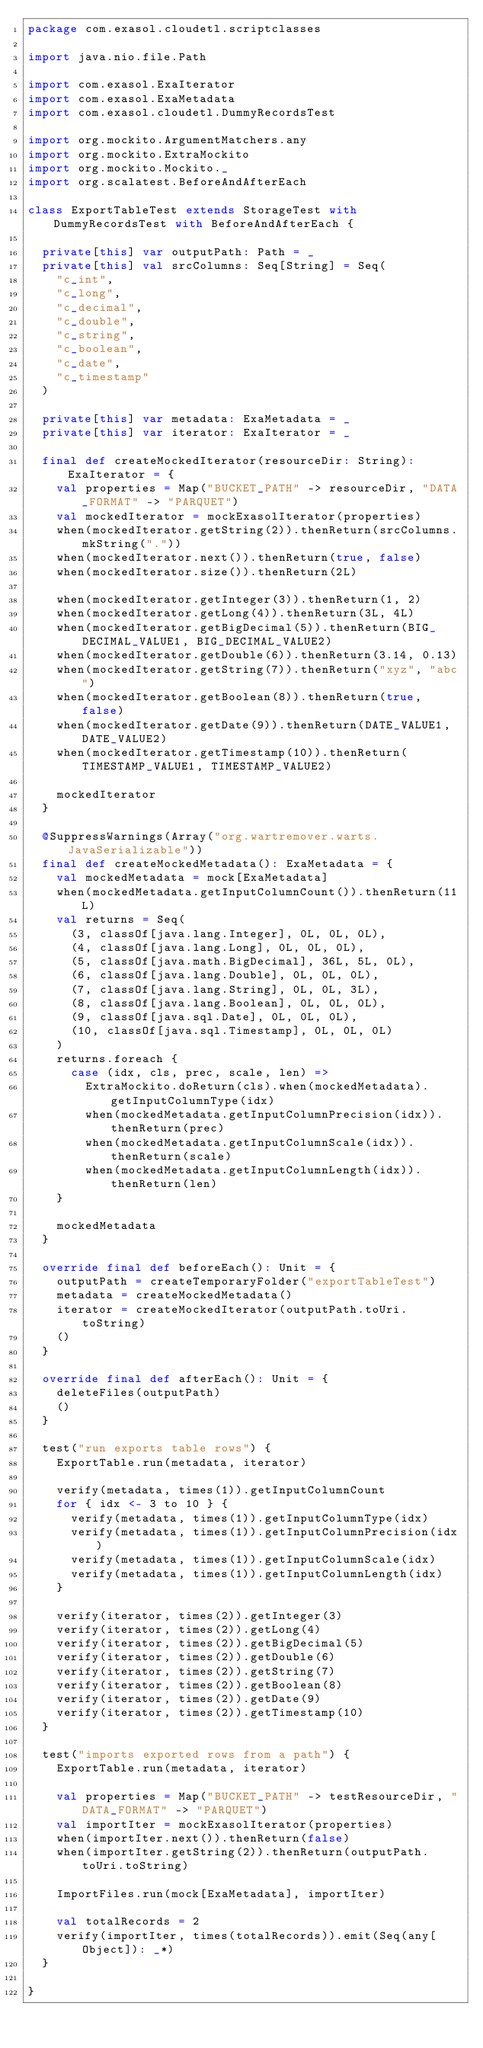Convert code to text. <code><loc_0><loc_0><loc_500><loc_500><_Scala_>package com.exasol.cloudetl.scriptclasses

import java.nio.file.Path

import com.exasol.ExaIterator
import com.exasol.ExaMetadata
import com.exasol.cloudetl.DummyRecordsTest

import org.mockito.ArgumentMatchers.any
import org.mockito.ExtraMockito
import org.mockito.Mockito._
import org.scalatest.BeforeAndAfterEach

class ExportTableTest extends StorageTest with DummyRecordsTest with BeforeAndAfterEach {

  private[this] var outputPath: Path = _
  private[this] val srcColumns: Seq[String] = Seq(
    "c_int",
    "c_long",
    "c_decimal",
    "c_double",
    "c_string",
    "c_boolean",
    "c_date",
    "c_timestamp"
  )

  private[this] var metadata: ExaMetadata = _
  private[this] var iterator: ExaIterator = _

  final def createMockedIterator(resourceDir: String): ExaIterator = {
    val properties = Map("BUCKET_PATH" -> resourceDir, "DATA_FORMAT" -> "PARQUET")
    val mockedIterator = mockExasolIterator(properties)
    when(mockedIterator.getString(2)).thenReturn(srcColumns.mkString("."))
    when(mockedIterator.next()).thenReturn(true, false)
    when(mockedIterator.size()).thenReturn(2L)

    when(mockedIterator.getInteger(3)).thenReturn(1, 2)
    when(mockedIterator.getLong(4)).thenReturn(3L, 4L)
    when(mockedIterator.getBigDecimal(5)).thenReturn(BIG_DECIMAL_VALUE1, BIG_DECIMAL_VALUE2)
    when(mockedIterator.getDouble(6)).thenReturn(3.14, 0.13)
    when(mockedIterator.getString(7)).thenReturn("xyz", "abc")
    when(mockedIterator.getBoolean(8)).thenReturn(true, false)
    when(mockedIterator.getDate(9)).thenReturn(DATE_VALUE1, DATE_VALUE2)
    when(mockedIterator.getTimestamp(10)).thenReturn(TIMESTAMP_VALUE1, TIMESTAMP_VALUE2)

    mockedIterator
  }

  @SuppressWarnings(Array("org.wartremover.warts.JavaSerializable"))
  final def createMockedMetadata(): ExaMetadata = {
    val mockedMetadata = mock[ExaMetadata]
    when(mockedMetadata.getInputColumnCount()).thenReturn(11L)
    val returns = Seq(
      (3, classOf[java.lang.Integer], 0L, 0L, 0L),
      (4, classOf[java.lang.Long], 0L, 0L, 0L),
      (5, classOf[java.math.BigDecimal], 36L, 5L, 0L),
      (6, classOf[java.lang.Double], 0L, 0L, 0L),
      (7, classOf[java.lang.String], 0L, 0L, 3L),
      (8, classOf[java.lang.Boolean], 0L, 0L, 0L),
      (9, classOf[java.sql.Date], 0L, 0L, 0L),
      (10, classOf[java.sql.Timestamp], 0L, 0L, 0L)
    )
    returns.foreach {
      case (idx, cls, prec, scale, len) =>
        ExtraMockito.doReturn(cls).when(mockedMetadata).getInputColumnType(idx)
        when(mockedMetadata.getInputColumnPrecision(idx)).thenReturn(prec)
        when(mockedMetadata.getInputColumnScale(idx)).thenReturn(scale)
        when(mockedMetadata.getInputColumnLength(idx)).thenReturn(len)
    }

    mockedMetadata
  }

  override final def beforeEach(): Unit = {
    outputPath = createTemporaryFolder("exportTableTest")
    metadata = createMockedMetadata()
    iterator = createMockedIterator(outputPath.toUri.toString)
    ()
  }

  override final def afterEach(): Unit = {
    deleteFiles(outputPath)
    ()
  }

  test("run exports table rows") {
    ExportTable.run(metadata, iterator)

    verify(metadata, times(1)).getInputColumnCount
    for { idx <- 3 to 10 } {
      verify(metadata, times(1)).getInputColumnType(idx)
      verify(metadata, times(1)).getInputColumnPrecision(idx)
      verify(metadata, times(1)).getInputColumnScale(idx)
      verify(metadata, times(1)).getInputColumnLength(idx)
    }

    verify(iterator, times(2)).getInteger(3)
    verify(iterator, times(2)).getLong(4)
    verify(iterator, times(2)).getBigDecimal(5)
    verify(iterator, times(2)).getDouble(6)
    verify(iterator, times(2)).getString(7)
    verify(iterator, times(2)).getBoolean(8)
    verify(iterator, times(2)).getDate(9)
    verify(iterator, times(2)).getTimestamp(10)
  }

  test("imports exported rows from a path") {
    ExportTable.run(metadata, iterator)

    val properties = Map("BUCKET_PATH" -> testResourceDir, "DATA_FORMAT" -> "PARQUET")
    val importIter = mockExasolIterator(properties)
    when(importIter.next()).thenReturn(false)
    when(importIter.getString(2)).thenReturn(outputPath.toUri.toString)

    ImportFiles.run(mock[ExaMetadata], importIter)

    val totalRecords = 2
    verify(importIter, times(totalRecords)).emit(Seq(any[Object]): _*)
  }

}
</code> 